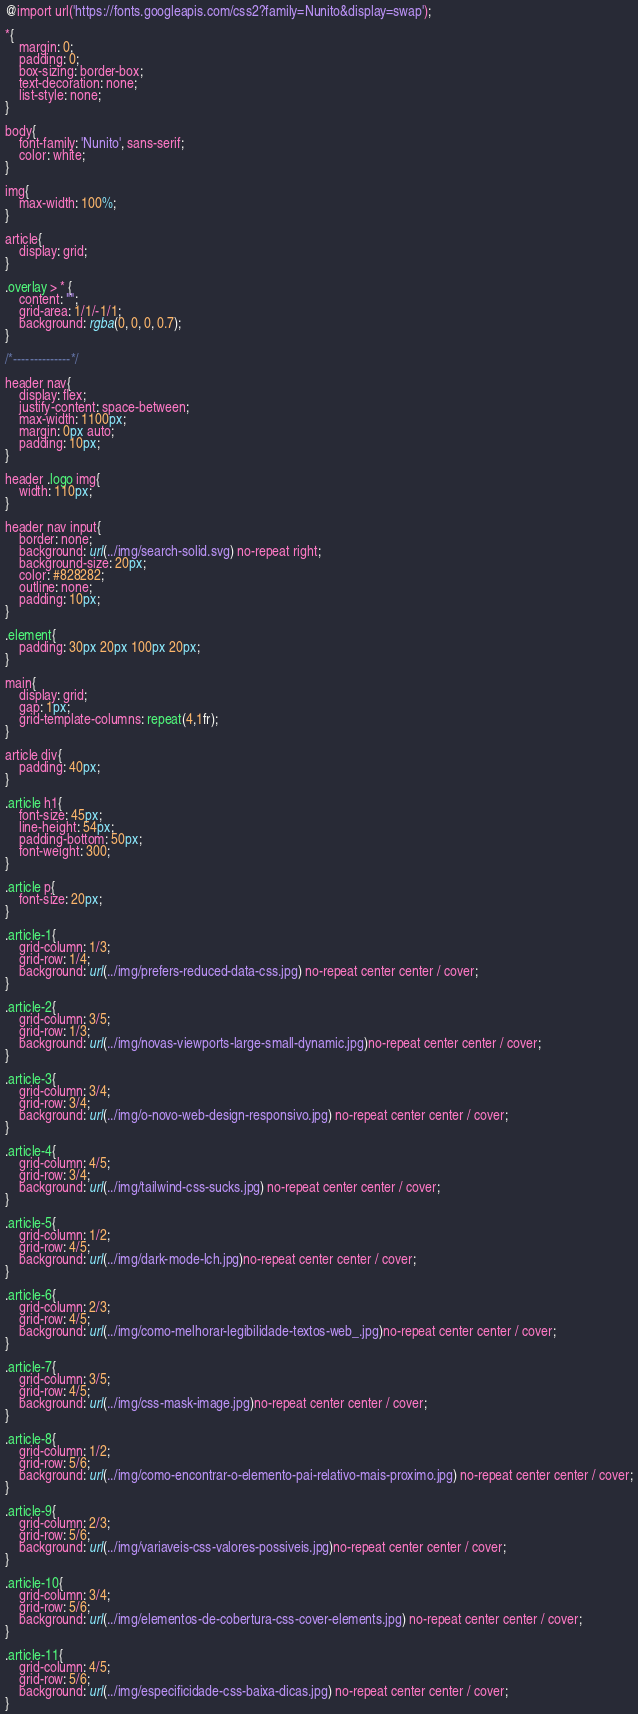<code> <loc_0><loc_0><loc_500><loc_500><_CSS_>@import url('https://fonts.googleapis.com/css2?family=Nunito&display=swap');

*{
    margin: 0;
    padding: 0;
    box-sizing: border-box;
    text-decoration: none;
    list-style: none;
}

body{
    font-family: 'Nunito', sans-serif;
    color: white;
}

img{
    max-width: 100%;
}

article{
    display: grid;
}

.overlay > * {
    content: "";
    grid-area: 1/1/-1/1;
    background: rgba(0, 0, 0, 0.7);
}

/*--------------*/

header nav{
    display: flex;
    justify-content: space-between;
    max-width: 1100px;
    margin: 0px auto;
    padding: 10px;
}

header .logo img{
    width: 110px;
}

header nav input{
    border: none;
    background: url(../img/search-solid.svg) no-repeat right;
    background-size: 20px;
    color: #828282;
    outline: none;
    padding: 10px;
}

.element{
    padding: 30px 20px 100px 20px;
}

main{
    display: grid;
    gap: 1px;
    grid-template-columns: repeat(4,1fr);
}

article div{
    padding: 40px;
}

.article h1{
    font-size: 45px;
    line-height: 54px;
    padding-bottom: 50px;
    font-weight: 300;
}

.article p{
    font-size: 20px;
}

.article-1{
    grid-column: 1/3;
    grid-row: 1/4;
    background: url(../img/prefers-reduced-data-css.jpg) no-repeat center center / cover;
}

.article-2{
    grid-column: 3/5;
    grid-row: 1/3;
    background: url(../img/novas-viewports-large-small-dynamic.jpg)no-repeat center center / cover;
}

.article-3{
    grid-column: 3/4;
    grid-row: 3/4;
    background: url(../img/o-novo-web-design-responsivo.jpg) no-repeat center center / cover;
}

.article-4{
    grid-column: 4/5;
    grid-row: 3/4;
    background: url(../img/tailwind-css-sucks.jpg) no-repeat center center / cover;
}

.article-5{
    grid-column: 1/2;
    grid-row: 4/5;
    background: url(../img/dark-mode-lch.jpg)no-repeat center center / cover;
}

.article-6{
    grid-column: 2/3;
    grid-row: 4/5;
    background: url(../img/como-melhorar-legibilidade-textos-web_.jpg)no-repeat center center / cover;
}

.article-7{
    grid-column: 3/5;
    grid-row: 4/5;
    background: url(../img/css-mask-image.jpg)no-repeat center center / cover;
}

.article-8{
    grid-column: 1/2;
    grid-row: 5/6;
    background: url(../img/como-encontrar-o-elemento-pai-relativo-mais-proximo.jpg) no-repeat center center / cover;
}

.article-9{
    grid-column: 2/3;
    grid-row: 5/6;
    background: url(../img/variaveis-css-valores-possiveis.jpg)no-repeat center center / cover;
}

.article-10{
    grid-column: 3/4;
    grid-row: 5/6;
    background: url(../img/elementos-de-cobertura-css-cover-elements.jpg) no-repeat center center / cover;
}

.article-11{
    grid-column: 4/5;
    grid-row: 5/6;
    background: url(../img/especificidade-css-baixa-dicas.jpg) no-repeat center center / cover;
}
</code> 